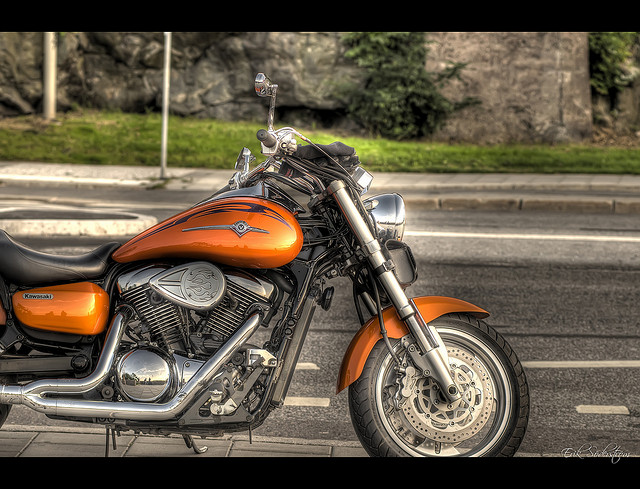<image>Why is only part of the motorcycle visible? The reason why only part of the motorcycle is visible is unclear. It might be due to the camera frame ending there or the picture cut off. Why is only part of the motorcycle visible? Only part of the motorcycle is visible because the camera frame ends there. 